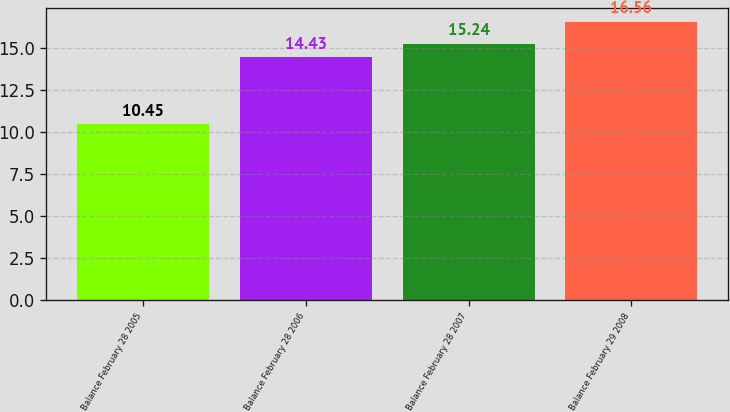Convert chart. <chart><loc_0><loc_0><loc_500><loc_500><bar_chart><fcel>Balance February 28 2005<fcel>Balance February 28 2006<fcel>Balance February 28 2007<fcel>Balance February 29 2008<nl><fcel>10.45<fcel>14.43<fcel>15.24<fcel>16.56<nl></chart> 